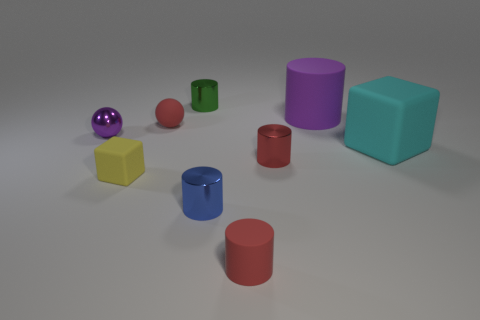There is a tiny red cylinder that is behind the block on the left side of the small green cylinder; what is its material?
Keep it short and to the point. Metal. There is a purple object that is left of the red thing behind the red metallic object that is to the left of the large cyan matte cube; what is its size?
Your response must be concise. Small. How many tiny balls are made of the same material as the tiny yellow cube?
Keep it short and to the point. 1. What is the color of the small metal object behind the metallic thing that is left of the small green thing?
Ensure brevity in your answer.  Green. What number of objects are either shiny spheres or small spheres behind the purple sphere?
Give a very brief answer. 2. Is there a small shiny object that has the same color as the tiny matte block?
Keep it short and to the point. No. What number of gray things are either tiny metallic things or large matte blocks?
Your answer should be very brief. 0. How many other things are there of the same size as the purple rubber thing?
Your response must be concise. 1. How many small things are yellow things or red cylinders?
Your answer should be compact. 3. There is a purple shiny thing; is it the same size as the red object that is behind the small purple shiny thing?
Make the answer very short. Yes. 